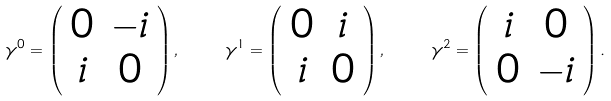<formula> <loc_0><loc_0><loc_500><loc_500>\gamma ^ { 0 } = \left ( \begin{array} { c c } { 0 } & { - i } \\ { i } & { 0 } \end{array} \right ) , \quad \gamma ^ { 1 } = \left ( \begin{array} { c c } { 0 } & { i } \\ { i } & { 0 } \end{array} \right ) , \quad \gamma ^ { 2 } = \left ( \begin{array} { c c } { i } & { 0 } \\ { 0 } & { - i } \end{array} \right ) .</formula> 